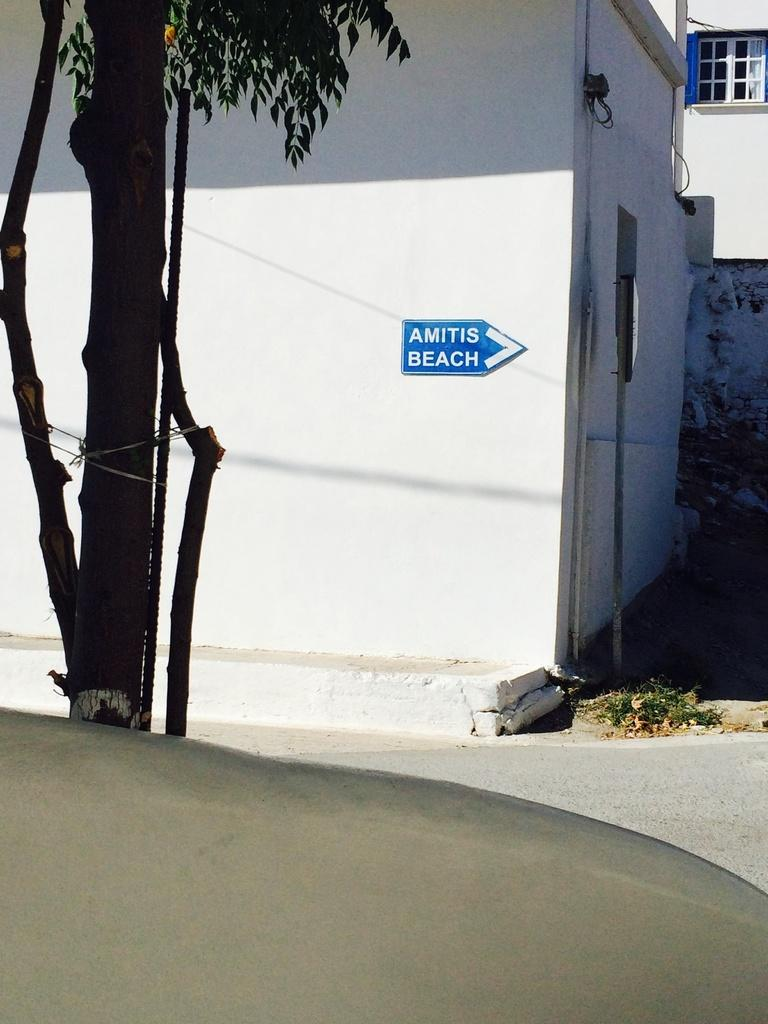What is located on the left side of the image? There is a tree trunk with leaves on the left side of the image. What can be seen in the background of the image? There are houses visible in the background of the image. Who is the creator of the sack seen in the image? There is no sack present in the image, so it is not possible to determine who its creator might be. 